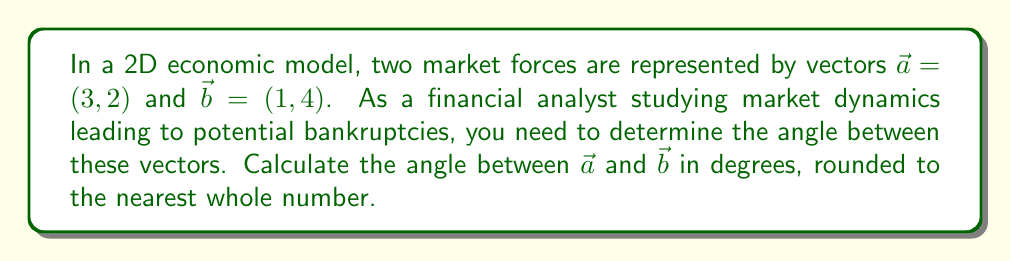Can you answer this question? To find the angle between two vectors, we can use the dot product formula:

$$\cos \theta = \frac{\vec{a} \cdot \vec{b}}{|\vec{a}||\vec{b}|}$$

Where $\theta$ is the angle between the vectors, $\vec{a} \cdot \vec{b}$ is the dot product, and $|\vec{a}|$ and $|\vec{b}|$ are the magnitudes of the vectors.

Step 1: Calculate the dot product $\vec{a} \cdot \vec{b}$
$$\vec{a} \cdot \vec{b} = (3 \times 1) + (2 \times 4) = 3 + 8 = 11$$

Step 2: Calculate the magnitudes of the vectors
$$|\vec{a}| = \sqrt{3^2 + 2^2} = \sqrt{13}$$
$$|\vec{b}| = \sqrt{1^2 + 4^2} = \sqrt{17}$$

Step 3: Substitute into the dot product formula
$$\cos \theta = \frac{11}{\sqrt{13} \times \sqrt{17}}$$

Step 4: Solve for $\theta$ using the inverse cosine (arccos) function
$$\theta = \arccos\left(\frac{11}{\sqrt{13} \times \sqrt{17}}\right)$$

Step 5: Convert to degrees and round to the nearest whole number
$$\theta \approx 44.42^\circ \approx 44^\circ$$

This angle represents the divergence between the two market forces, which could be indicative of market instability or conflicting economic pressures that might contribute to financial distress or potential bankruptcies.
Answer: 44° 